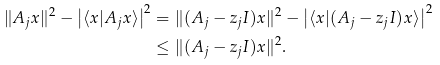<formula> <loc_0><loc_0><loc_500><loc_500>\| A _ { j } x \| ^ { 2 } - \left | \langle x | A _ { j } x \rangle \right | ^ { 2 } & = \| ( A _ { j } - z _ { j } I ) x \| ^ { 2 } - \left | \langle x | ( A _ { j } - z _ { j } I ) x \rangle \right | ^ { 2 } \\ & \leq \| ( A _ { j } - z _ { j } I ) x \| ^ { 2 } .</formula> 